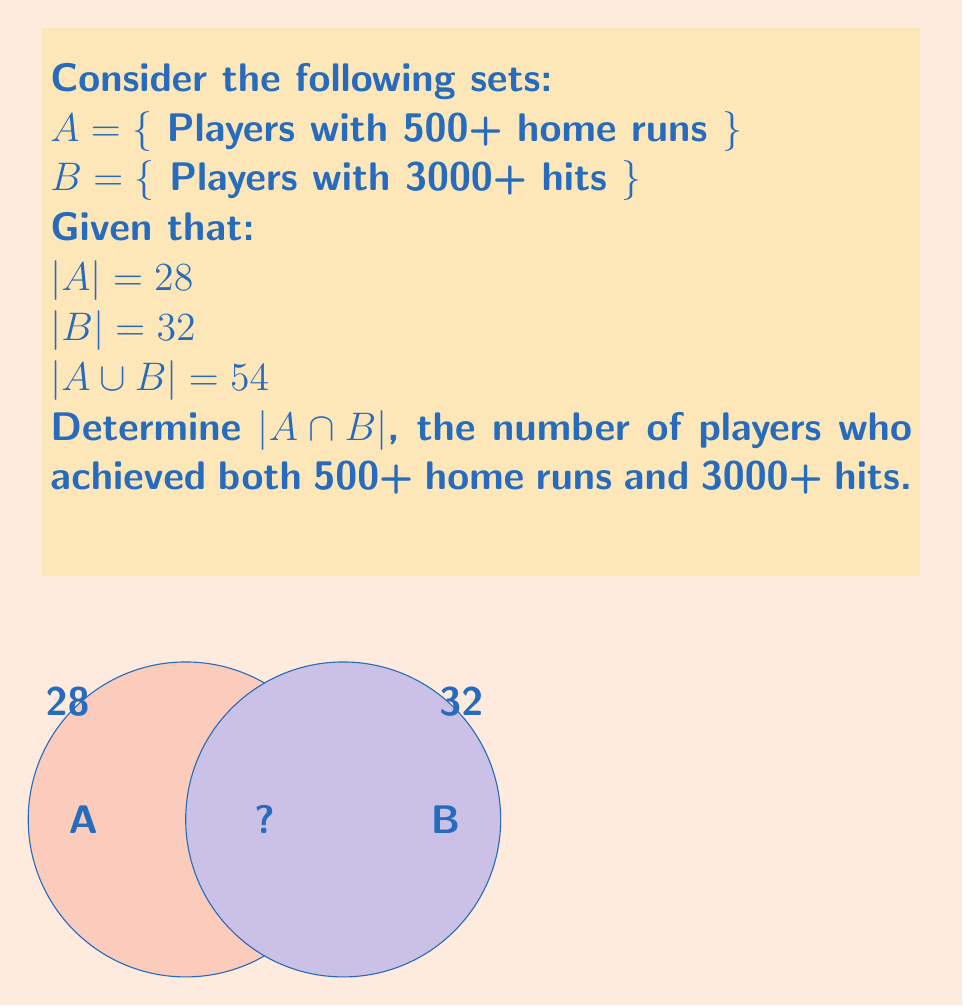Can you answer this question? Let's approach this step-by-step using set theory:

1) First, recall the formula for the number of elements in the union of two sets:

   $|A \cup B| = |A| + |B| - |A \cap B|$

2) We're given:
   $|A \cup B| = 54$
   $|A| = 28$
   $|B| = 32$

3) Let's substitute these values into our formula:

   $54 = 28 + 32 - |A \cap B|$

4) Now, let's solve for $|A \cap B|$:

   $54 = 60 - |A \cap B|$
   $|A \cap B| = 60 - 54 = 6$

Therefore, there are 6 players who achieved both 500+ home runs and 3000+ hits.
Answer: $|A \cap B| = 6$ 